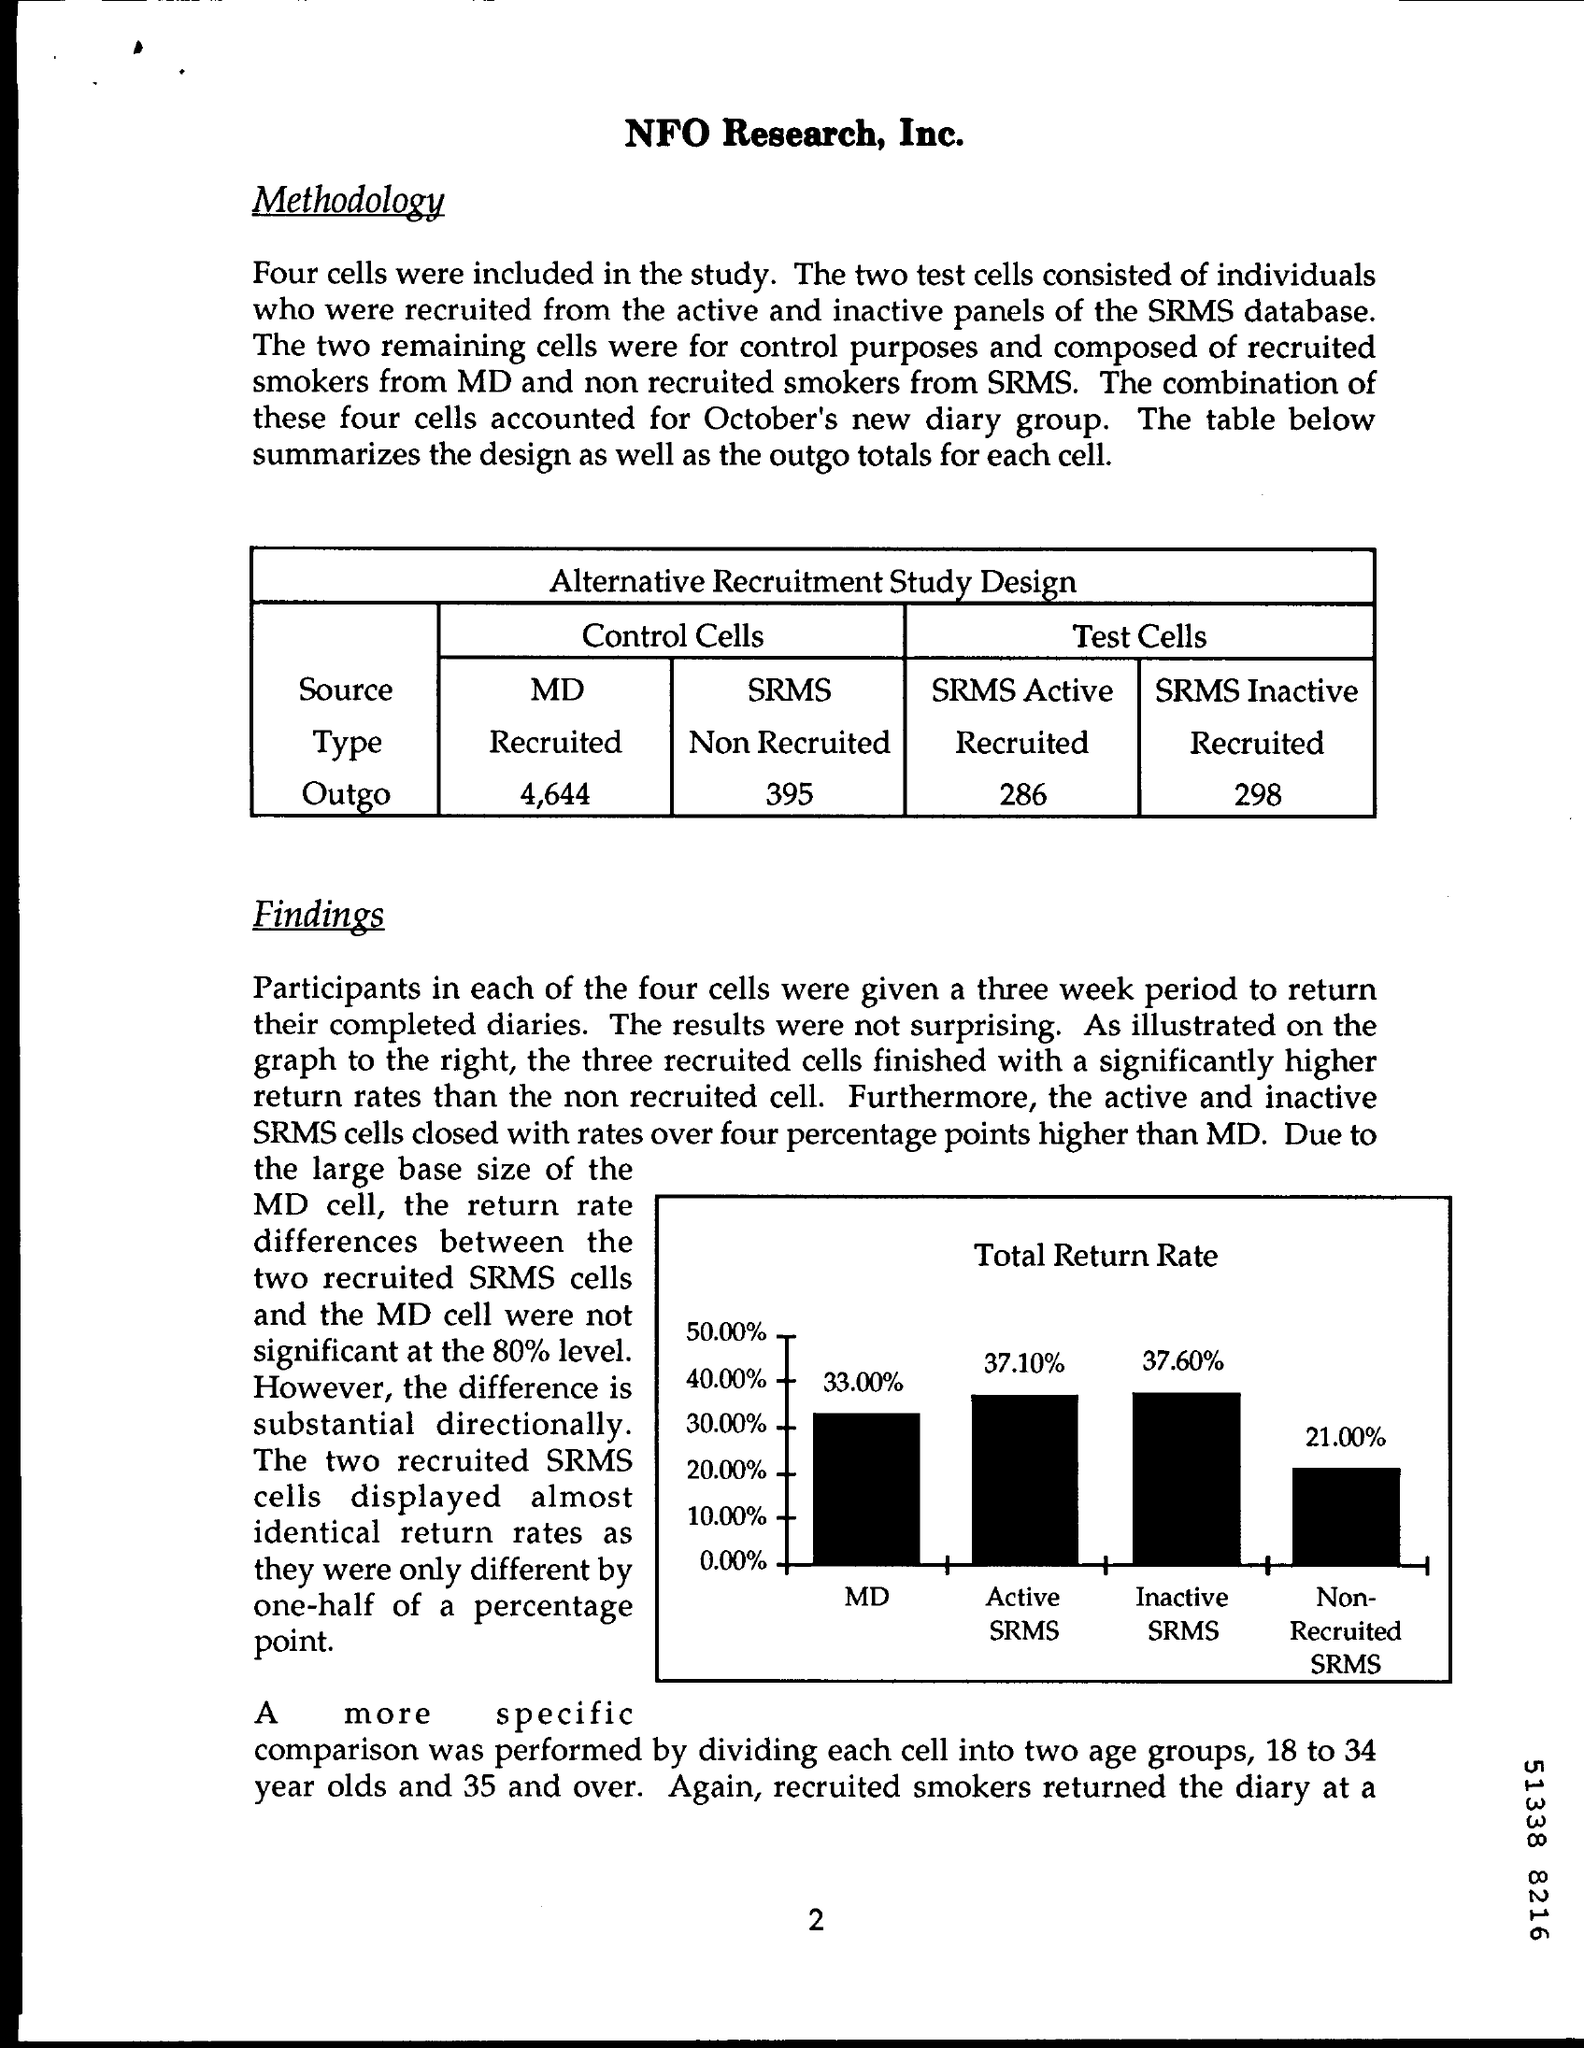What is the value of outgo of md cells in the control cells ?
Offer a very short reply. 4,644. What is the type of srms cells in control cells ?
Make the answer very short. Non recruited. What is the value of outgo in srms active in the test cells ?
Your answer should be compact. 286. What is the type of srms inactive in the test cells ?
Ensure brevity in your answer.  Recruited. 